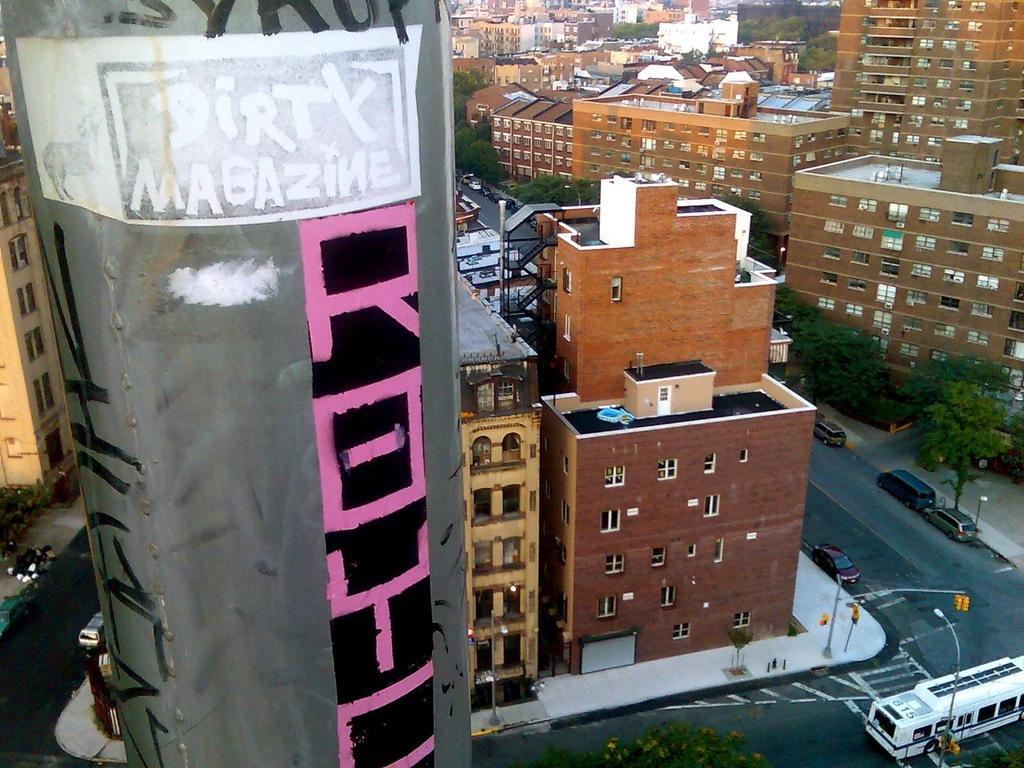Can you describe this image briefly? In this picture I can see vehicles on the road, there are poles, lights, there are buildings and trees. 